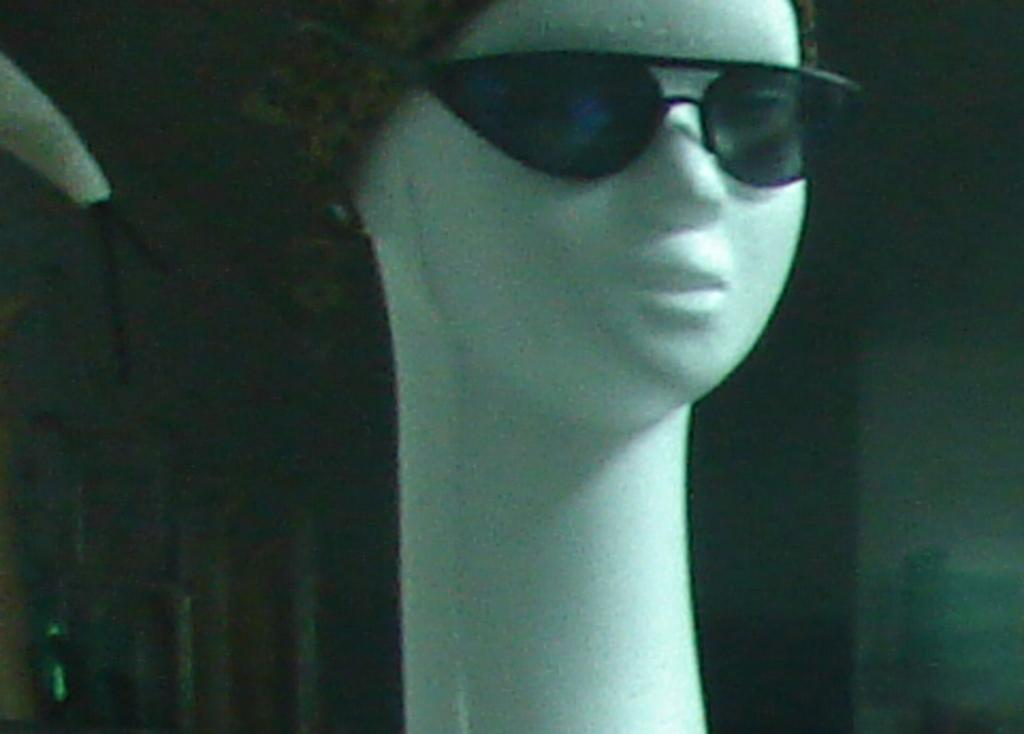What is the main subject of the image? The main subject of the image is a doll. What is the doll wearing in the image? The doll is wearing goggles in the image. Can you describe the background of the image? The background of the image is dark. What type of vacation is the doll planning in the image? There is no indication in the image that the doll is planning a vacation, as it is a doll wearing goggles with a dark background. Is the doll using a skate in the image? There is no skate present in the image; the doll is wearing goggles and is in a dark background. 